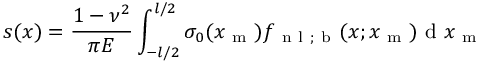<formula> <loc_0><loc_0><loc_500><loc_500>s ( x ) = \frac { 1 - \nu ^ { 2 } } { \pi E } \int _ { - l / 2 } ^ { l / 2 } \sigma _ { 0 } ( x _ { m } ) f _ { n l ; b } ( x ; x _ { m } ) d x _ { m }</formula> 